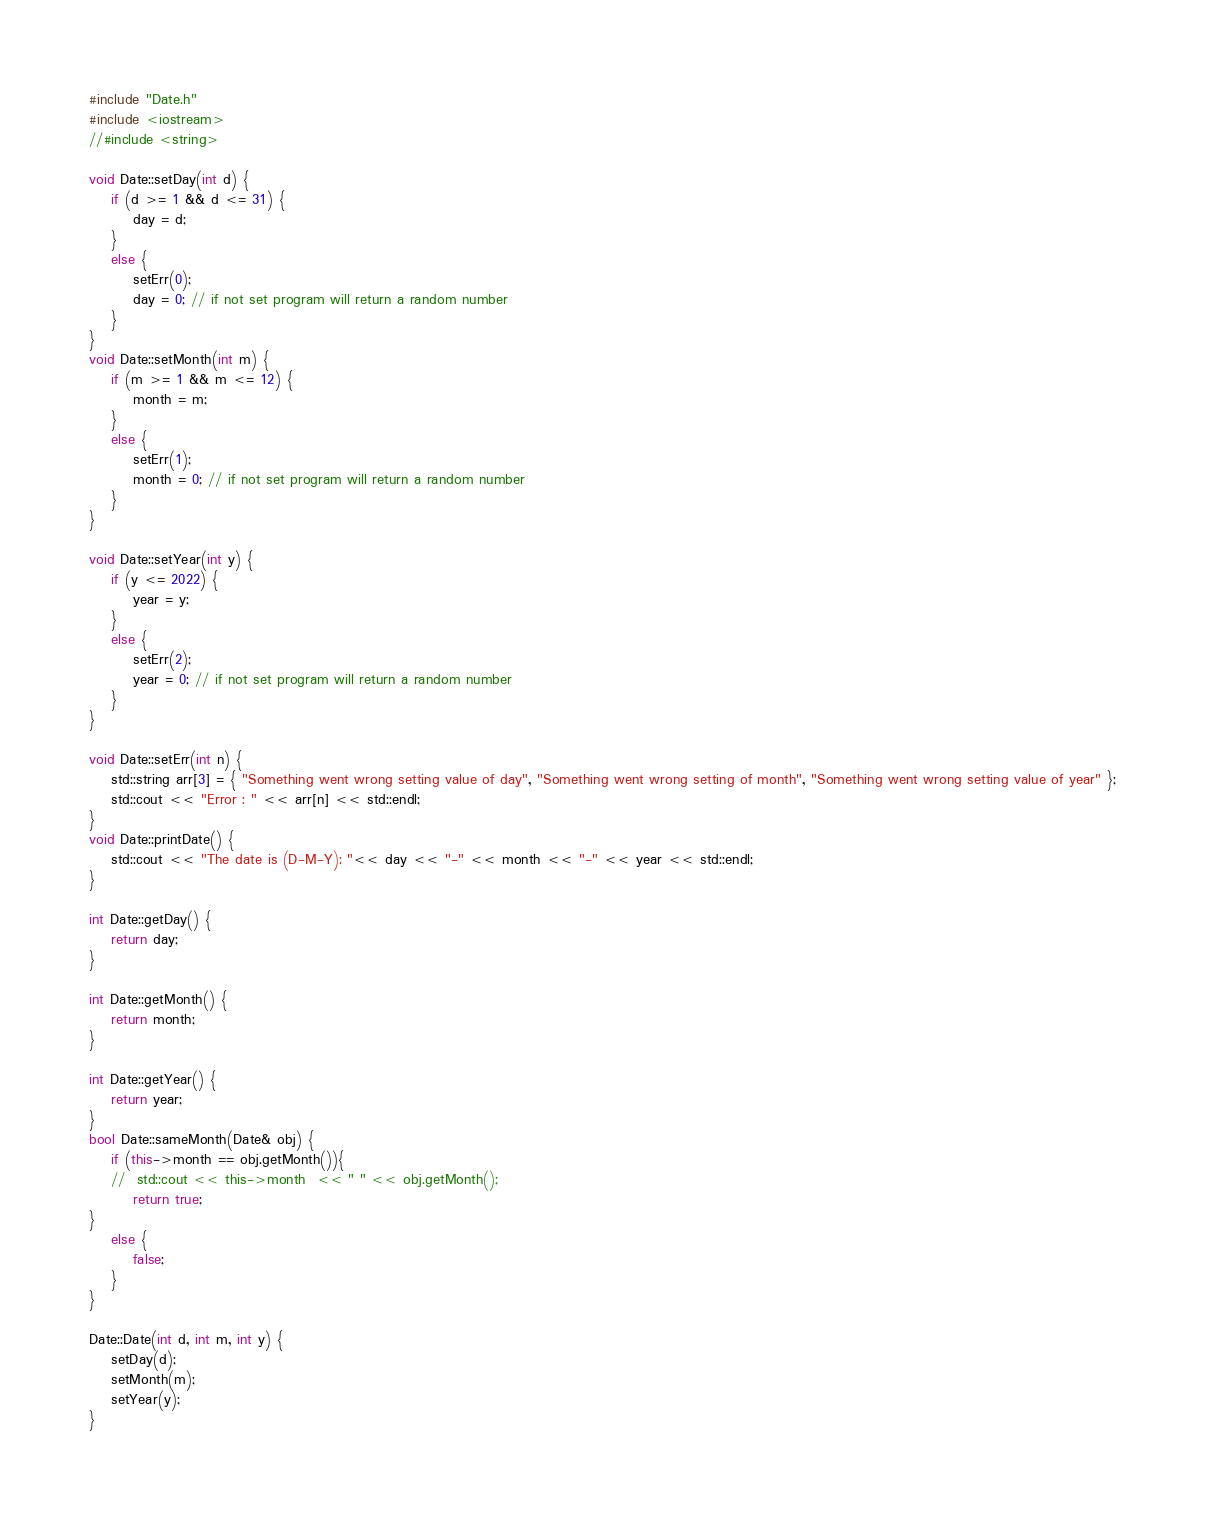Convert code to text. <code><loc_0><loc_0><loc_500><loc_500><_C++_>#include "Date.h"
#include <iostream>
//#include <string>

void Date::setDay(int d) {
	if (d >= 1 && d <= 31) {
		day = d;
	}
	else {
		setErr(0);
		day = 0; // if not set program will return a random number
	}
}
void Date::setMonth(int m) {
	if (m >= 1 && m <= 12) {
		month = m;
	}
	else {
		setErr(1);
		month = 0; // if not set program will return a random number
	}
}

void Date::setYear(int y) {
	if (y <= 2022) {
		year = y;
	}
	else {
		setErr(2);
		year = 0; // if not set program will return a random number
	}
}

void Date::setErr(int n) {
	std::string arr[3] = { "Something went wrong setting value of day", "Something went wrong setting of month", "Something went wrong setting value of year" };
	std::cout << "Error : " << arr[n] << std::endl;
}
void Date::printDate() {
	std::cout << "The date is (D-M-Y): "<< day << "-" << month << "-" << year << std::endl;
}

int Date::getDay() {
	return day;
}

int Date::getMonth() {
	return month;
}

int Date::getYear() {
	return year;
}
bool Date::sameMonth(Date& obj) {
	if (this->month == obj.getMonth()){
	//	std::cout << this->month  << " " << obj.getMonth();
		return true;
}
	else {
		false;
	}
}

Date::Date(int d, int m, int y) {
	setDay(d);
	setMonth(m);
	setYear(y);
}
</code> 